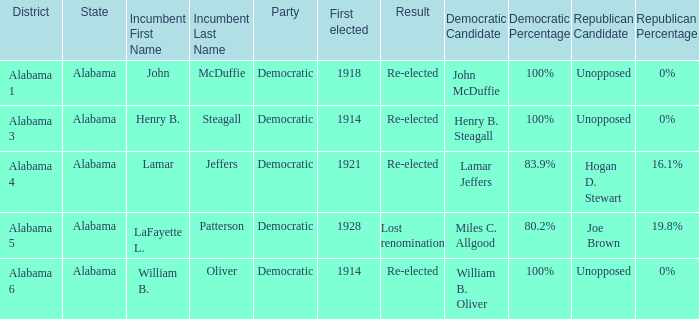Could you parse the entire table? {'header': ['District', 'State', 'Incumbent First Name', 'Incumbent Last Name', 'Party', 'First elected', 'Result', 'Democratic Candidate', 'Democratic Percentage', 'Republican Candidate', 'Republican Percentage'], 'rows': [['Alabama 1', 'Alabama', 'John', 'McDuffie', 'Democratic', '1918', 'Re-elected', 'John McDuffie', '100%', 'Unopposed', '0%'], ['Alabama 3', 'Alabama', 'Henry B.', 'Steagall', 'Democratic', '1914', 'Re-elected', 'Henry B. Steagall', '100%', 'Unopposed', '0%'], ['Alabama 4', 'Alabama', 'Lamar', 'Jeffers', 'Democratic', '1921', 'Re-elected', 'Lamar Jeffers', '83.9%', 'Hogan D. Stewart', '16.1%'], ['Alabama 5', 'Alabama', 'LaFayette L.', 'Patterson', 'Democratic', '1928', 'Lost renomination', 'Miles C. Allgood', '80.2%', 'Joe Brown', '19.8%'], ['Alabama 6', 'Alabama', 'William B.', 'Oliver', 'Democratic', '1914', 'Re-elected', 'William B. Oliver', '100%', 'Unopposed', '0%']]} How many in total were elected first in lost renomination? 1.0. 